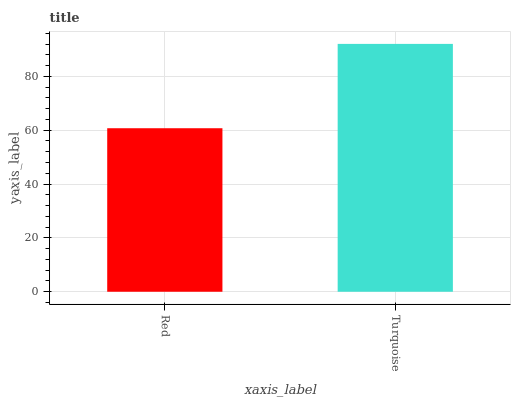Is Red the minimum?
Answer yes or no. Yes. Is Turquoise the maximum?
Answer yes or no. Yes. Is Turquoise the minimum?
Answer yes or no. No. Is Turquoise greater than Red?
Answer yes or no. Yes. Is Red less than Turquoise?
Answer yes or no. Yes. Is Red greater than Turquoise?
Answer yes or no. No. Is Turquoise less than Red?
Answer yes or no. No. Is Turquoise the high median?
Answer yes or no. Yes. Is Red the low median?
Answer yes or no. Yes. Is Red the high median?
Answer yes or no. No. Is Turquoise the low median?
Answer yes or no. No. 